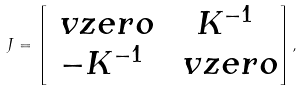<formula> <loc_0><loc_0><loc_500><loc_500>J = \begin{bmatrix} \ v z e r o & K ^ { - 1 } \\ - K ^ { - 1 } & \ v z e r o \end{bmatrix} ,</formula> 